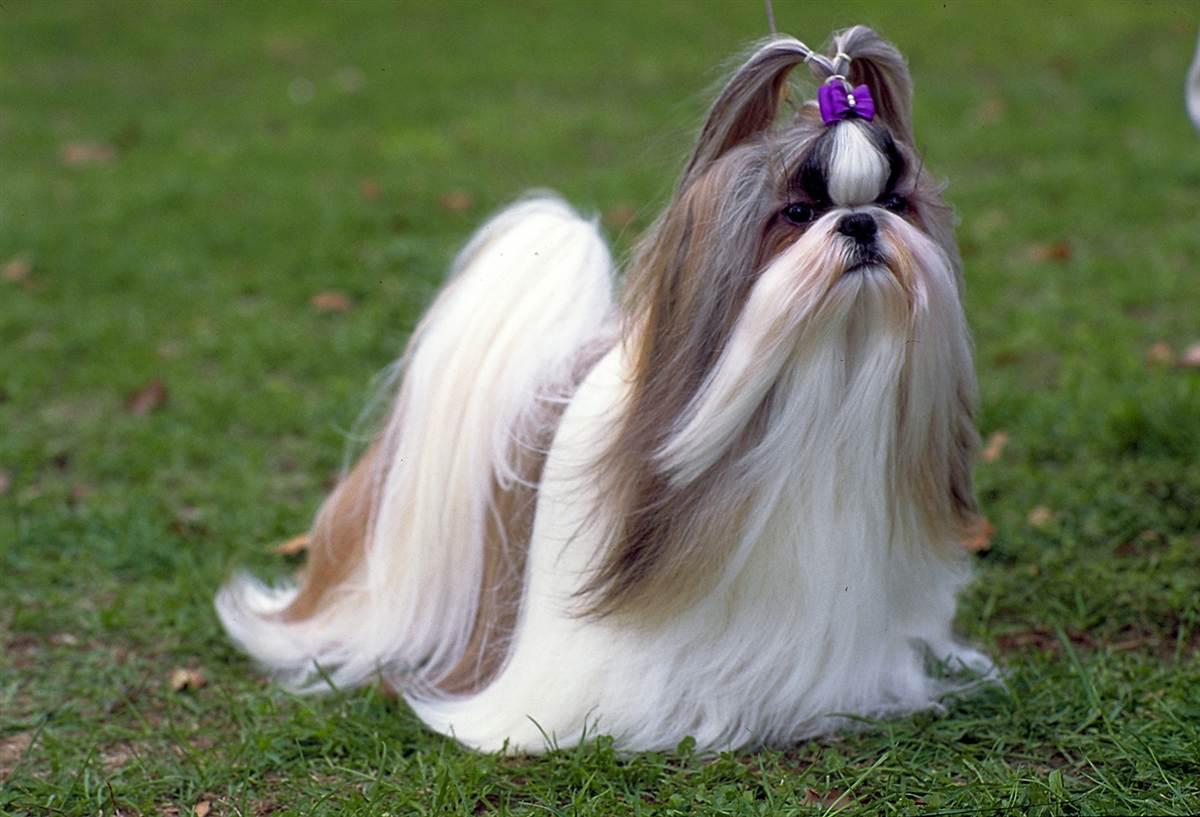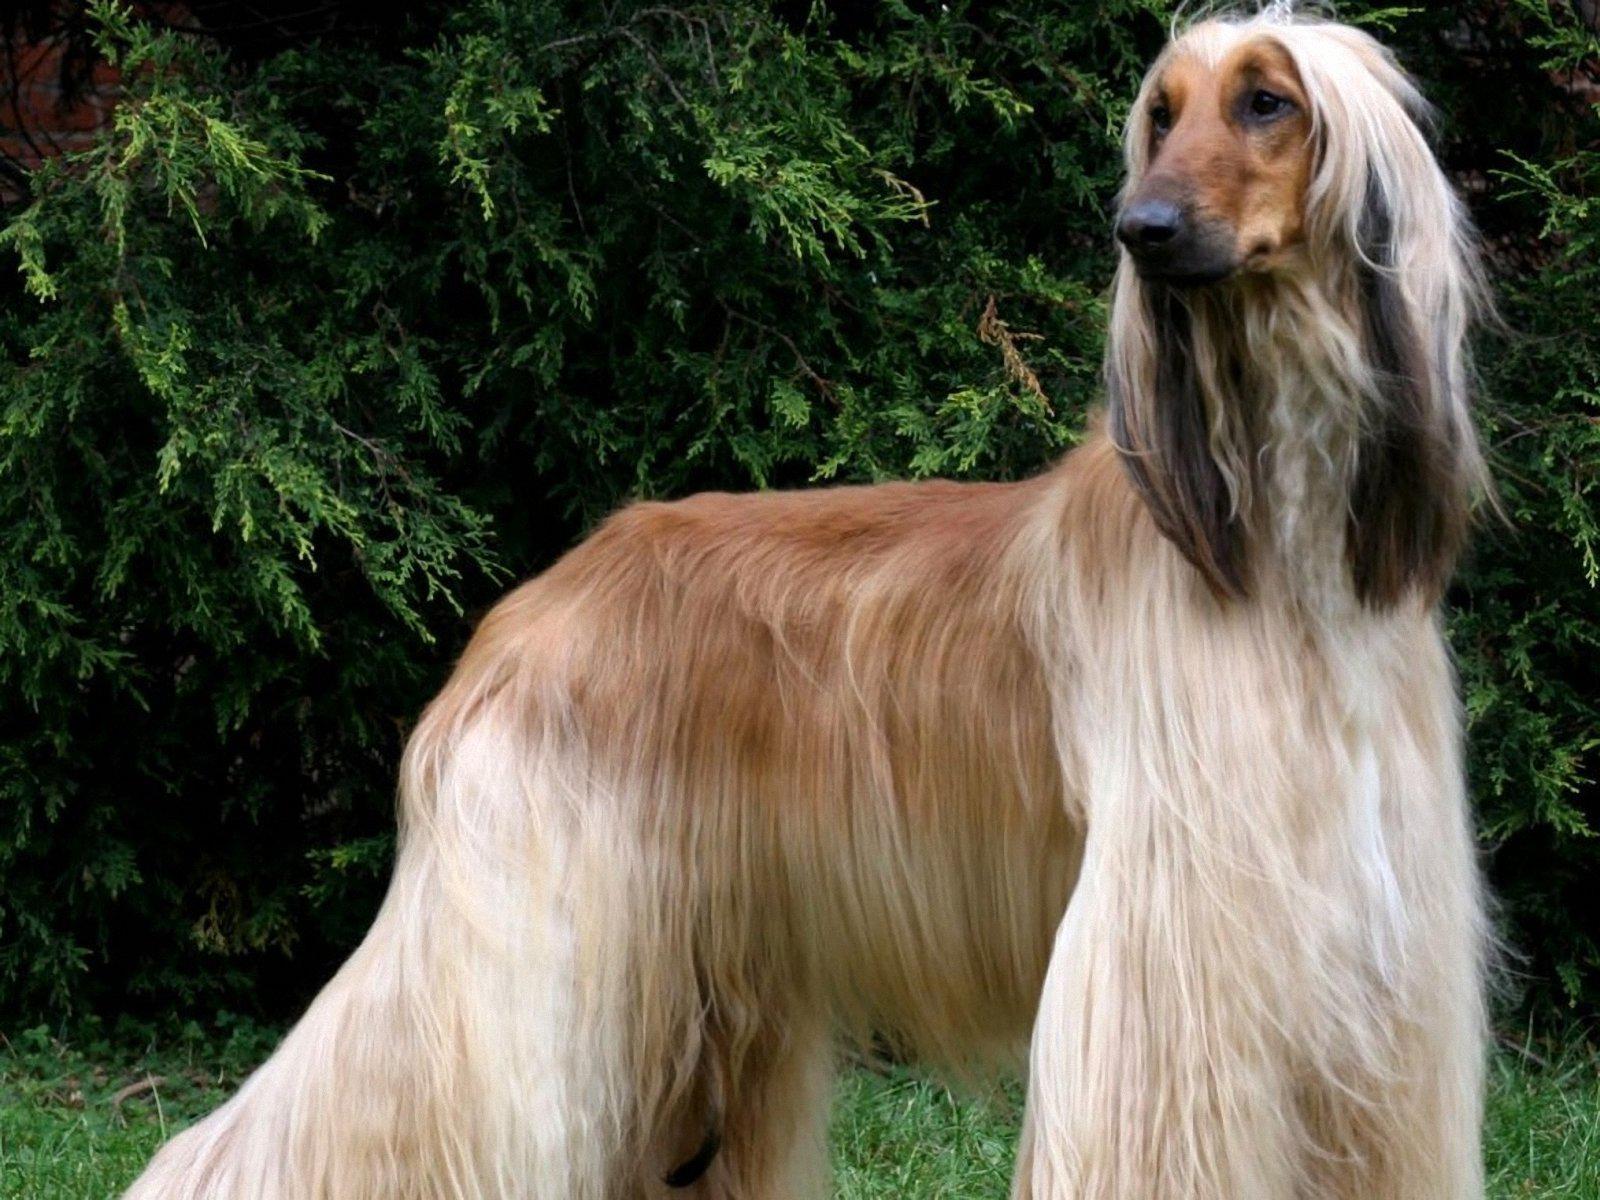The first image is the image on the left, the second image is the image on the right. For the images displayed, is the sentence "In one of the images, there is at least one dog sitting down" factually correct? Answer yes or no. No. 